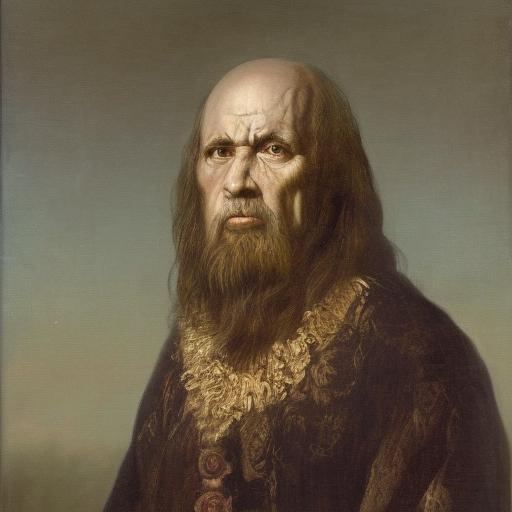What era does this portrait represent? The portrait seems to evoke the Renaissance period, notable for the rich attire and the classic pose reminiscent of paintings from the 14th to 17th centuries. Can you tell me more about the attire in the portrait? Certainly! The subject is adorned with a luxurious, fur-lined robe that features intricately embroidered gold patterns. Such attire would indicate a person of high status, possibly royalty or nobility during the Renaissance. 